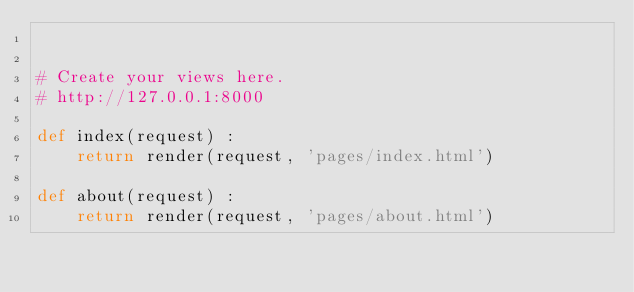<code> <loc_0><loc_0><loc_500><loc_500><_Python_>

# Create your views here.
# http://127.0.0.1:8000

def index(request) :
    return render(request, 'pages/index.html')

def about(request) :
    return render(request, 'pages/about.html')</code> 